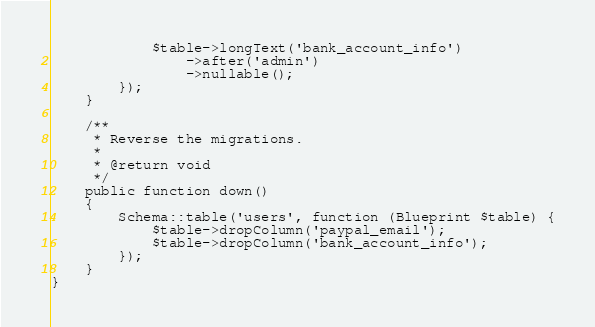Convert code to text. <code><loc_0><loc_0><loc_500><loc_500><_PHP_>            $table->longText('bank_account_info')
                ->after('admin')
                ->nullable();
        });
    }

    /**
     * Reverse the migrations.
     *
     * @return void
     */
    public function down()
    {
        Schema::table('users', function (Blueprint $table) {
            $table->dropColumn('paypal_email');
            $table->dropColumn('bank_account_info');
        });
    }
}
</code> 